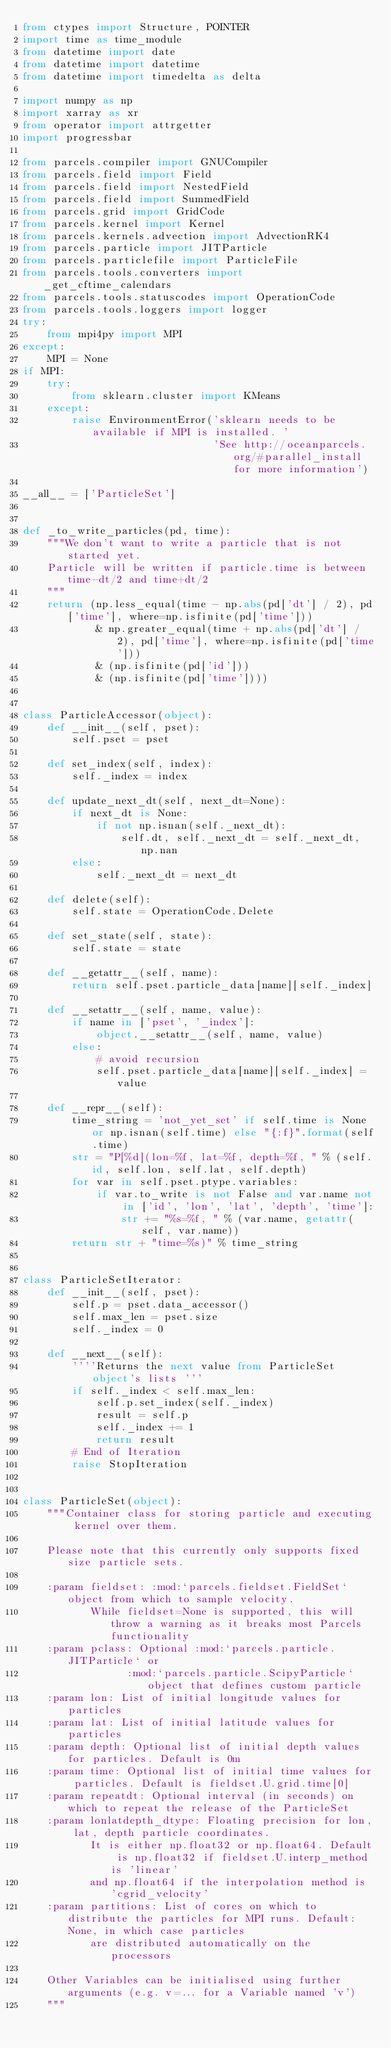<code> <loc_0><loc_0><loc_500><loc_500><_Python_>from ctypes import Structure, POINTER
import time as time_module
from datetime import date
from datetime import datetime
from datetime import timedelta as delta

import numpy as np
import xarray as xr
from operator import attrgetter
import progressbar

from parcels.compiler import GNUCompiler
from parcels.field import Field
from parcels.field import NestedField
from parcels.field import SummedField
from parcels.grid import GridCode
from parcels.kernel import Kernel
from parcels.kernels.advection import AdvectionRK4
from parcels.particle import JITParticle
from parcels.particlefile import ParticleFile
from parcels.tools.converters import _get_cftime_calendars
from parcels.tools.statuscodes import OperationCode
from parcels.tools.loggers import logger
try:
    from mpi4py import MPI
except:
    MPI = None
if MPI:
    try:
        from sklearn.cluster import KMeans
    except:
        raise EnvironmentError('sklearn needs to be available if MPI is installed. '
                               'See http://oceanparcels.org/#parallel_install for more information')

__all__ = ['ParticleSet']


def _to_write_particles(pd, time):
    """We don't want to write a particle that is not started yet.
    Particle will be written if particle.time is between time-dt/2 and time+dt/2
    """
    return (np.less_equal(time - np.abs(pd['dt'] / 2), pd['time'], where=np.isfinite(pd['time']))
            & np.greater_equal(time + np.abs(pd['dt'] / 2), pd['time'], where=np.isfinite(pd['time']))
            & (np.isfinite(pd['id']))
            & (np.isfinite(pd['time'])))


class ParticleAccessor(object):
    def __init__(self, pset):
        self.pset = pset

    def set_index(self, index):
        self._index = index

    def update_next_dt(self, next_dt=None):
        if next_dt is None:
            if not np.isnan(self._next_dt):
                self.dt, self._next_dt = self._next_dt, np.nan
        else:
            self._next_dt = next_dt

    def delete(self):
        self.state = OperationCode.Delete

    def set_state(self, state):
        self.state = state

    def __getattr__(self, name):
        return self.pset.particle_data[name][self._index]

    def __setattr__(self, name, value):
        if name in ['pset', '_index']:
            object.__setattr__(self, name, value)
        else:
            # avoid recursion
            self.pset.particle_data[name][self._index] = value

    def __repr__(self):
        time_string = 'not_yet_set' if self.time is None or np.isnan(self.time) else "{:f}".format(self.time)
        str = "P[%d](lon=%f, lat=%f, depth=%f, " % (self.id, self.lon, self.lat, self.depth)
        for var in self.pset.ptype.variables:
            if var.to_write is not False and var.name not in ['id', 'lon', 'lat', 'depth', 'time']:
                str += "%s=%f, " % (var.name, getattr(self, var.name))
        return str + "time=%s)" % time_string


class ParticleSetIterator:
    def __init__(self, pset):
        self.p = pset.data_accessor()
        self.max_len = pset.size
        self._index = 0

    def __next__(self):
        ''''Returns the next value from ParticleSet object's lists '''
        if self._index < self.max_len:
            self.p.set_index(self._index)
            result = self.p
            self._index += 1
            return result
        # End of Iteration
        raise StopIteration


class ParticleSet(object):
    """Container class for storing particle and executing kernel over them.

    Please note that this currently only supports fixed size particle sets.

    :param fieldset: :mod:`parcels.fieldset.FieldSet` object from which to sample velocity.
           While fieldset=None is supported, this will throw a warning as it breaks most Parcels functionality
    :param pclass: Optional :mod:`parcels.particle.JITParticle` or
                 :mod:`parcels.particle.ScipyParticle` object that defines custom particle
    :param lon: List of initial longitude values for particles
    :param lat: List of initial latitude values for particles
    :param depth: Optional list of initial depth values for particles. Default is 0m
    :param time: Optional list of initial time values for particles. Default is fieldset.U.grid.time[0]
    :param repeatdt: Optional interval (in seconds) on which to repeat the release of the ParticleSet
    :param lonlatdepth_dtype: Floating precision for lon, lat, depth particle coordinates.
           It is either np.float32 or np.float64. Default is np.float32 if fieldset.U.interp_method is 'linear'
           and np.float64 if the interpolation method is 'cgrid_velocity'
    :param partitions: List of cores on which to distribute the particles for MPI runs. Default: None, in which case particles
           are distributed automatically on the processors

    Other Variables can be initialised using further arguments (e.g. v=... for a Variable named 'v')
    """
</code> 